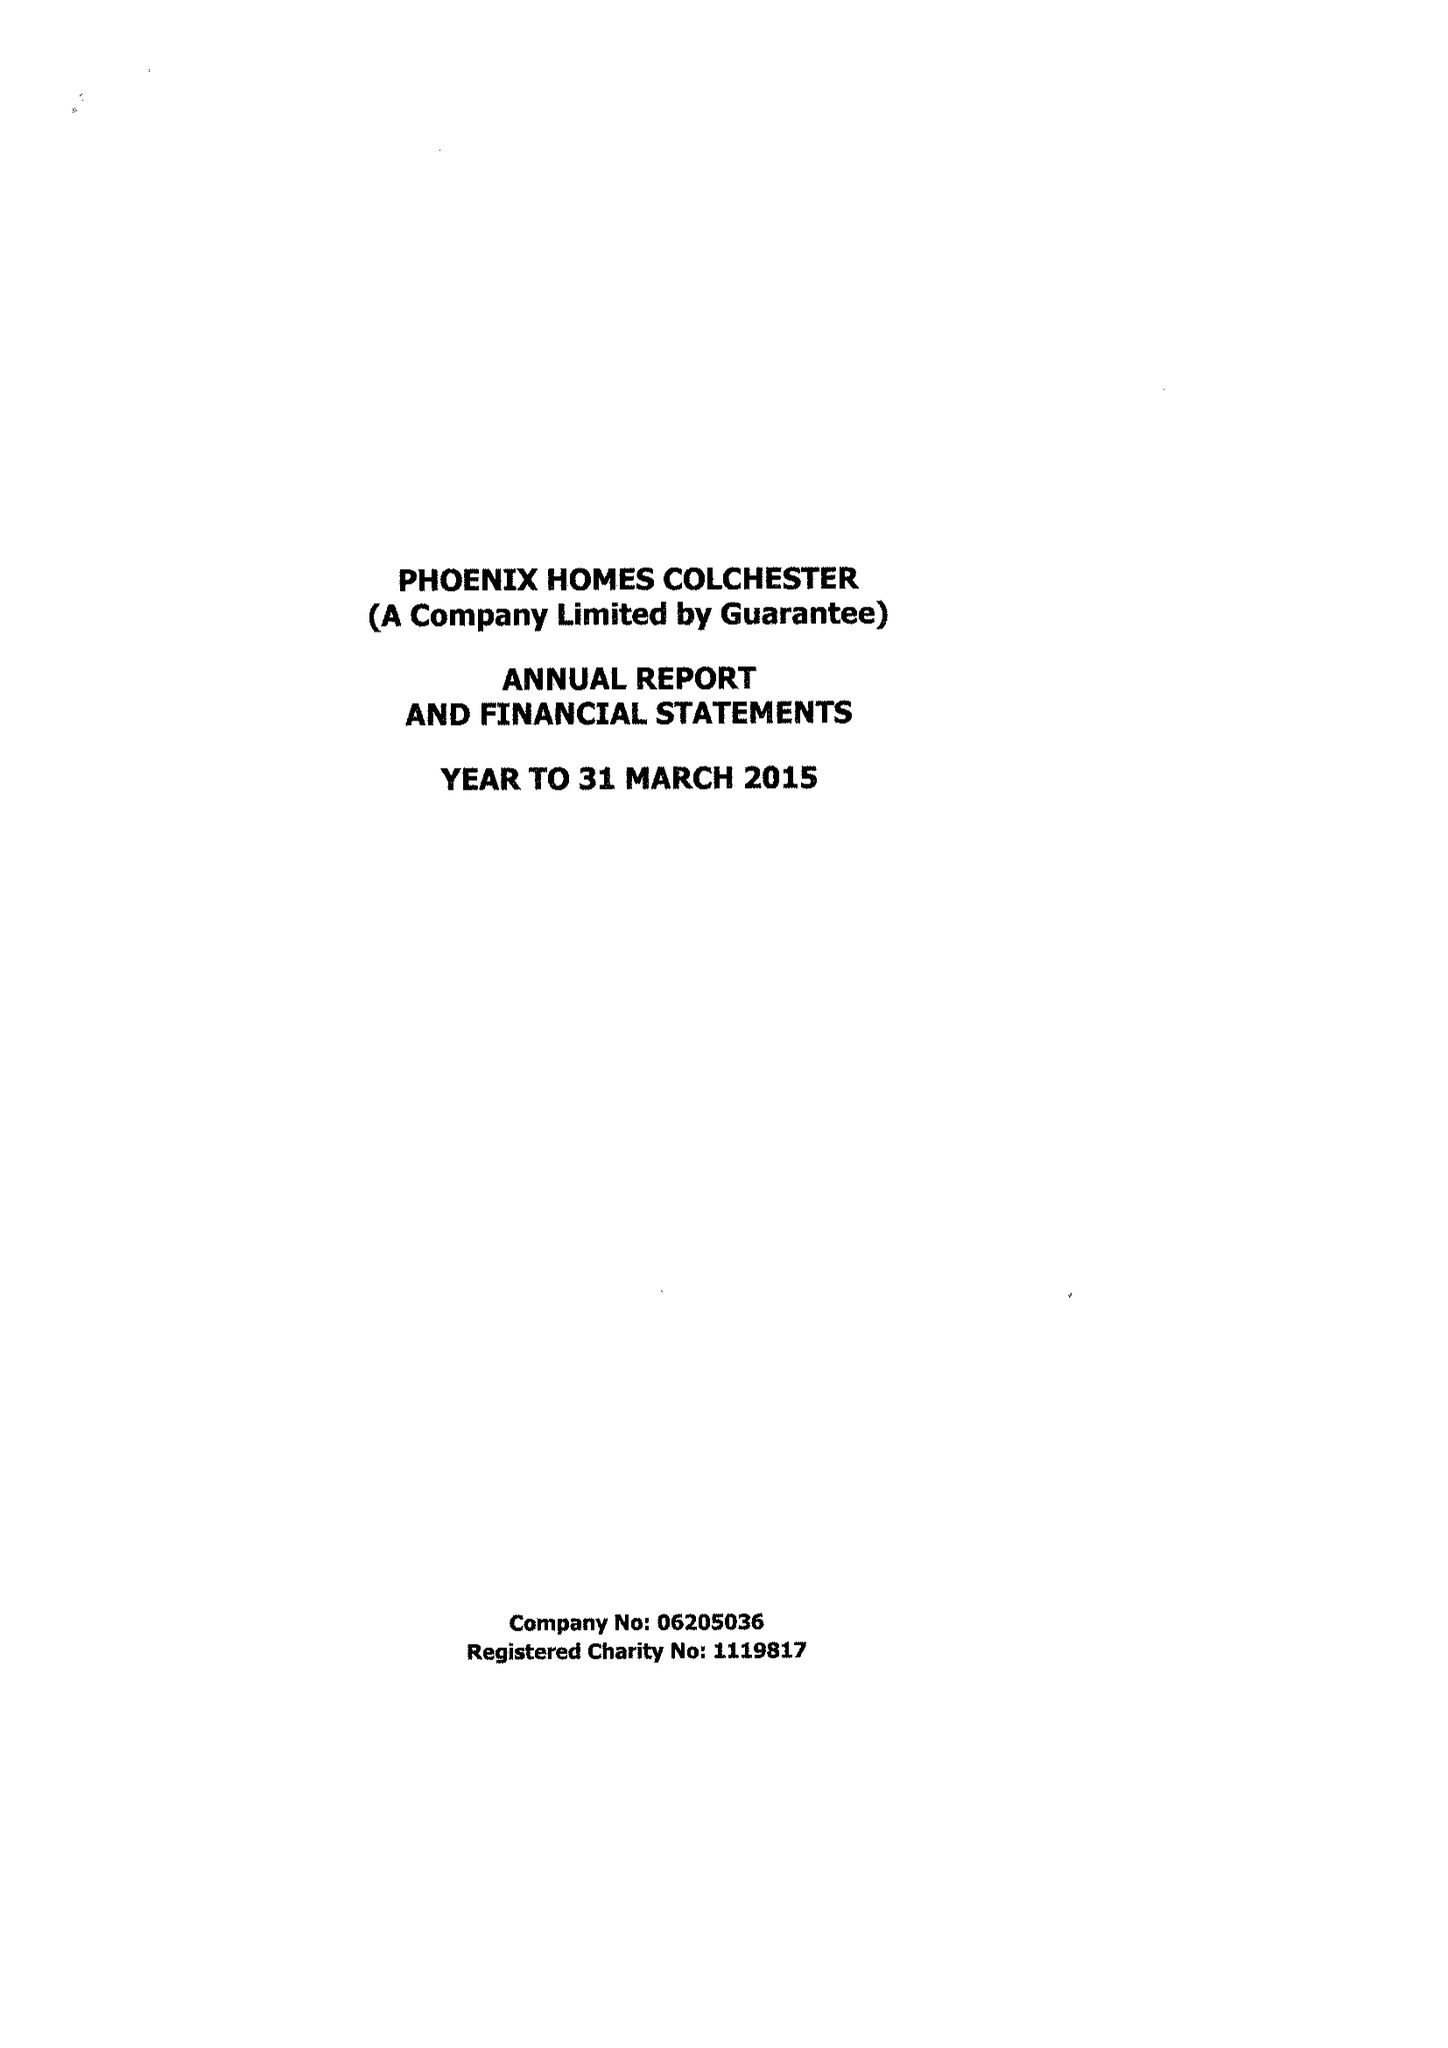What is the value for the spending_annually_in_british_pounds?
Answer the question using a single word or phrase. 417267.00 